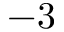Convert formula to latex. <formula><loc_0><loc_0><loc_500><loc_500>- 3</formula> 